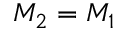Convert formula to latex. <formula><loc_0><loc_0><loc_500><loc_500>M _ { 2 } = M _ { 1 }</formula> 